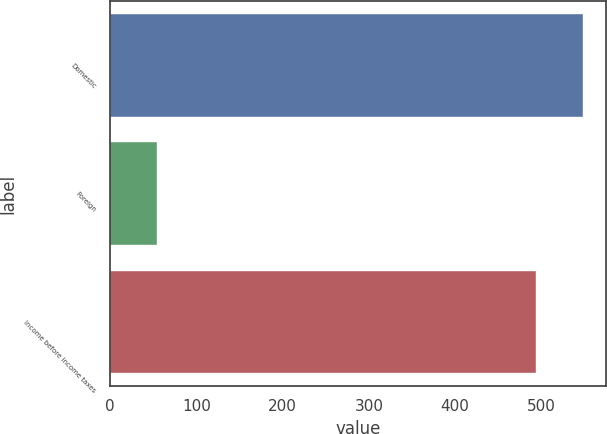<chart> <loc_0><loc_0><loc_500><loc_500><bar_chart><fcel>Domestic<fcel>Foreign<fcel>Income before income taxes<nl><fcel>548<fcel>54<fcel>494<nl></chart> 